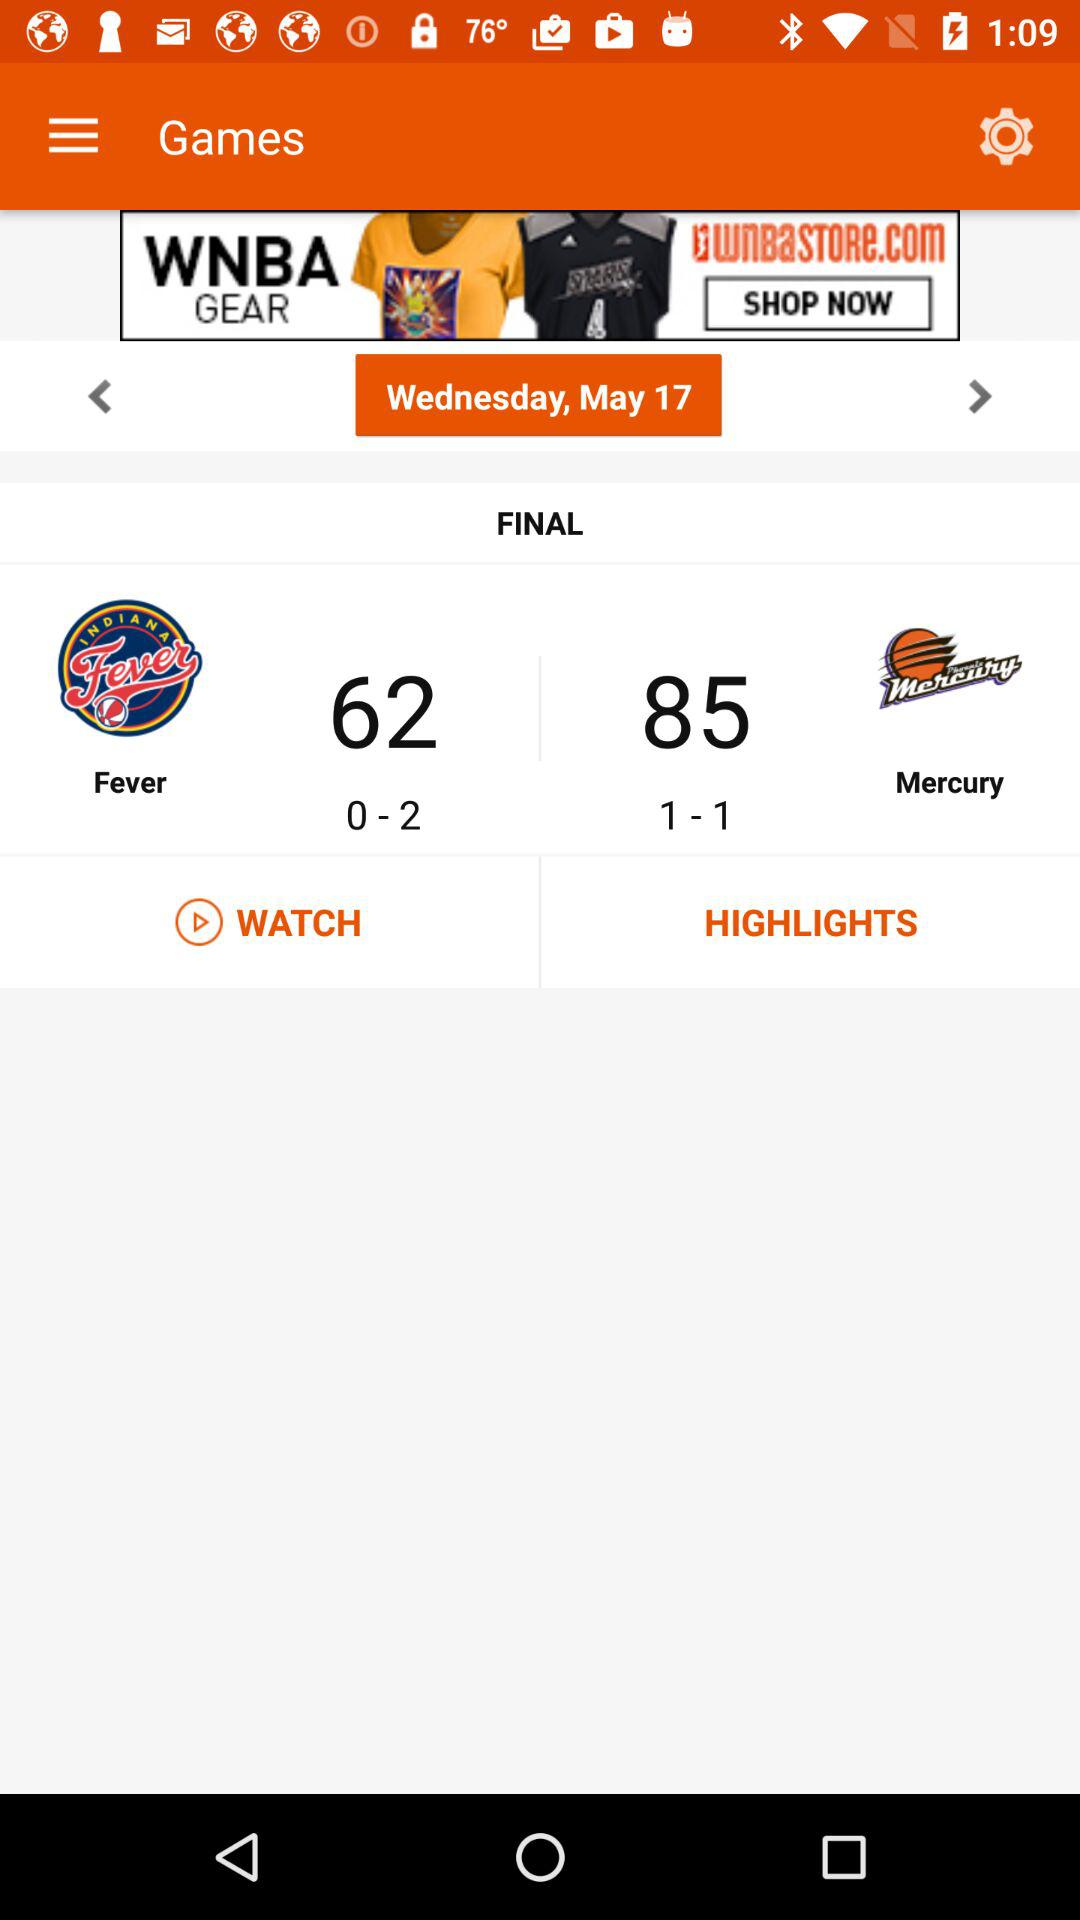What is the total score of the "Fever"? The total score of the "Fever" is 62. 